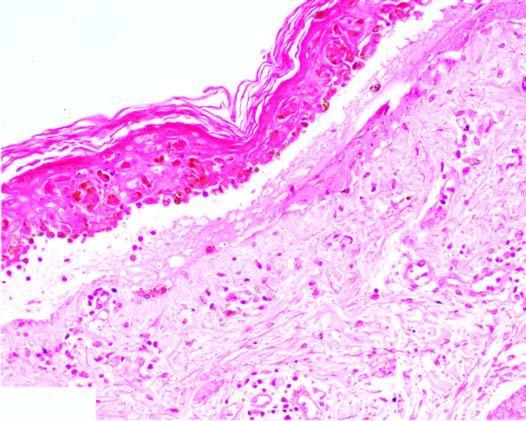what is there of kertinocytes at the junction and mild lymphocytic infiltrate?
Answer the question using a single word or phrase. Oedema and necrosis 